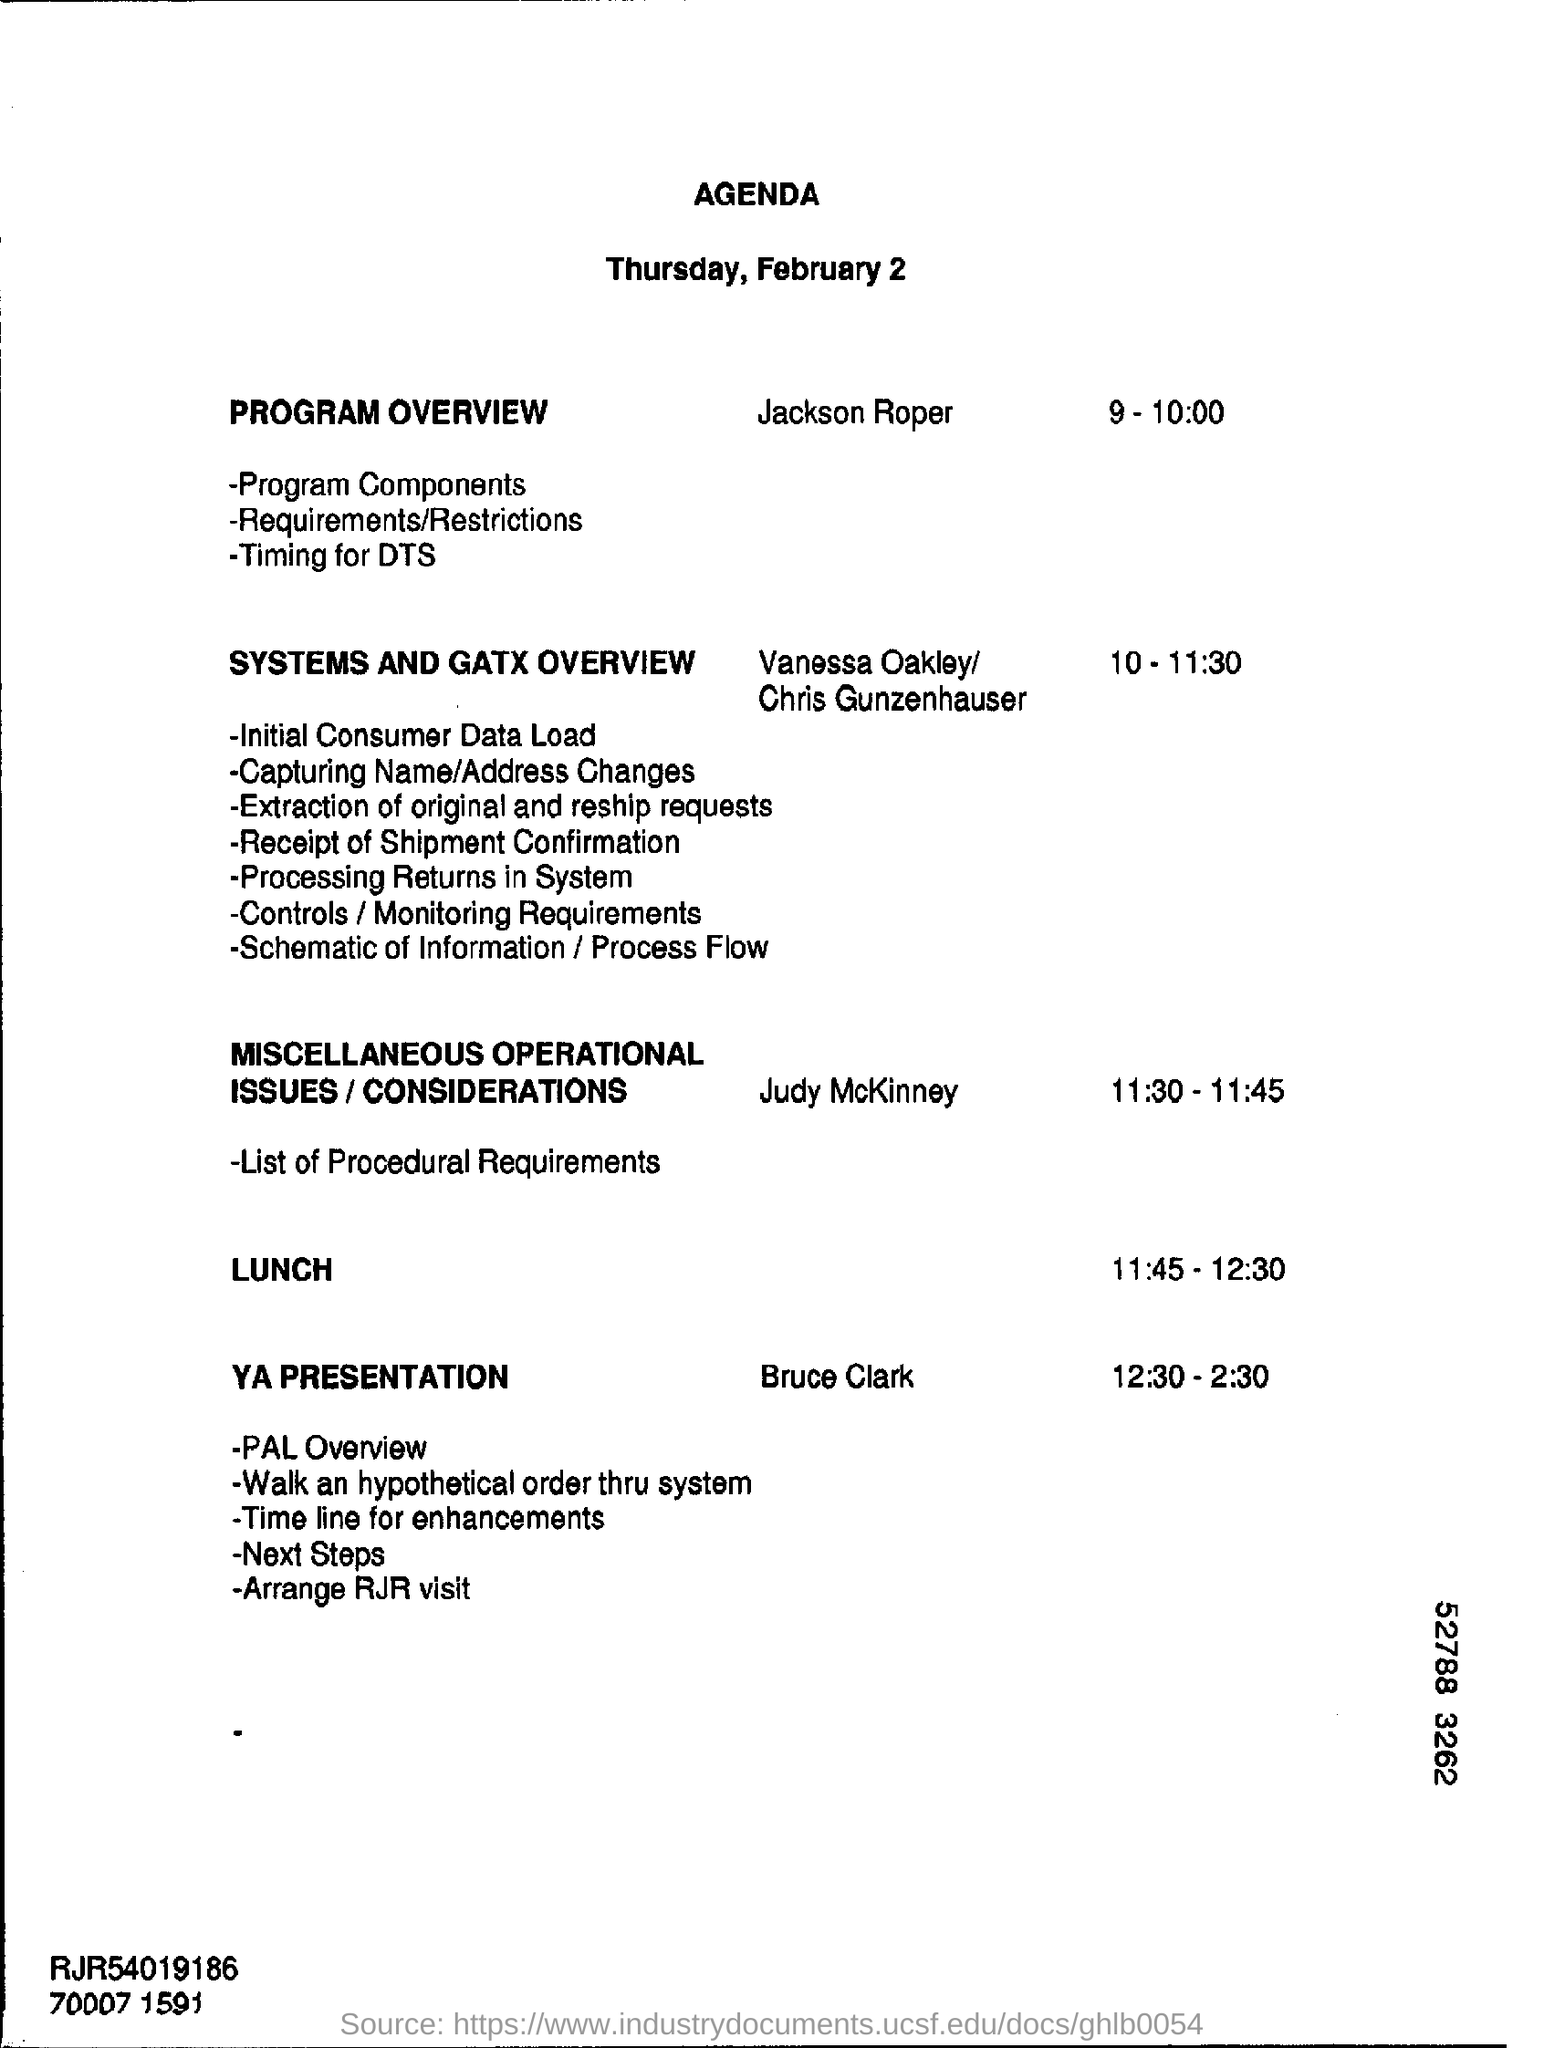What is the date mentioned in the given page ?
Give a very brief answer. Thursday, February 2. What is the schedule at the time of 9-10:00 ?
Offer a very short reply. Program overview. What is the schedule at the time of 10-11:30 ?
Make the answer very short. Systems and gatx overview. What is the schedule time for lunch ?
Provide a short and direct response. 11:45 - 12:30. 